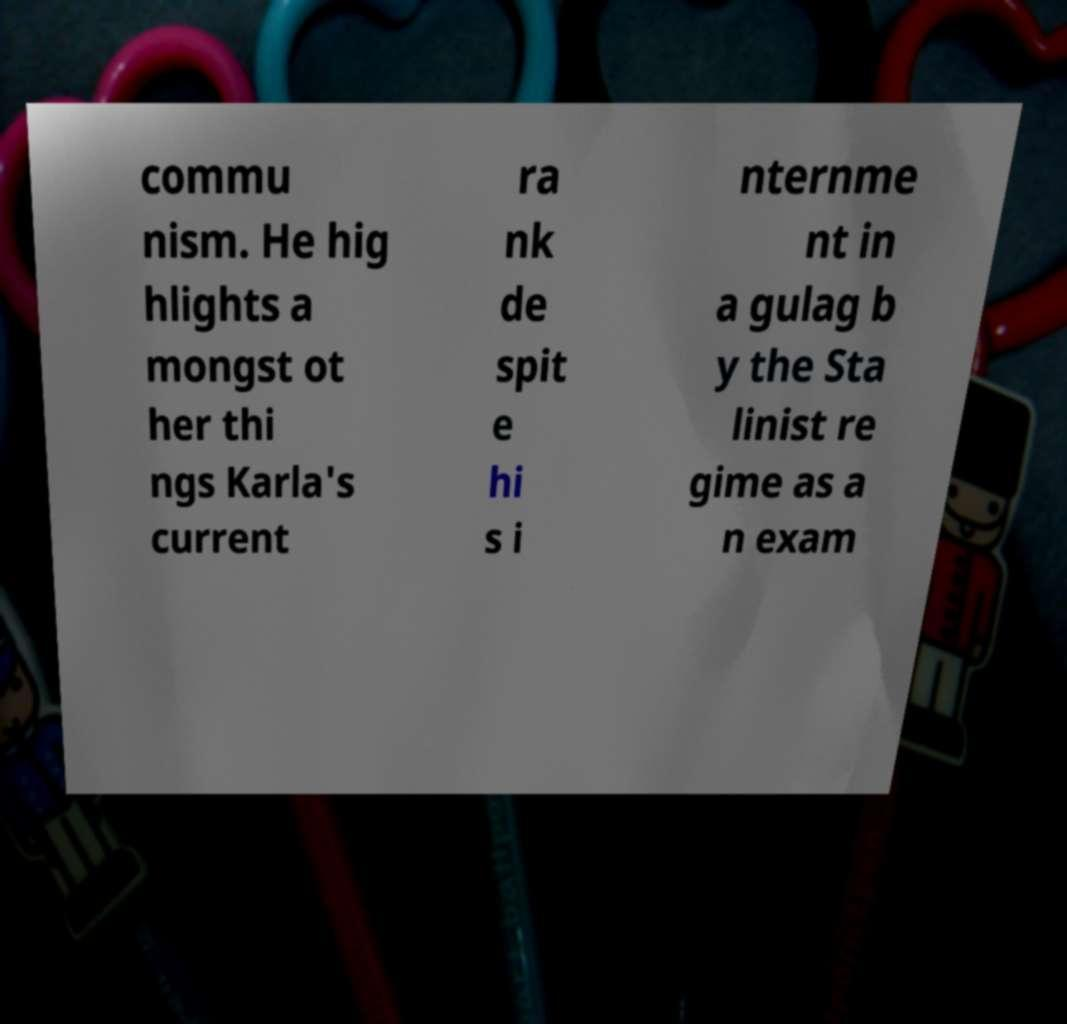Could you assist in decoding the text presented in this image and type it out clearly? commu nism. He hig hlights a mongst ot her thi ngs Karla's current ra nk de spit e hi s i nternme nt in a gulag b y the Sta linist re gime as a n exam 